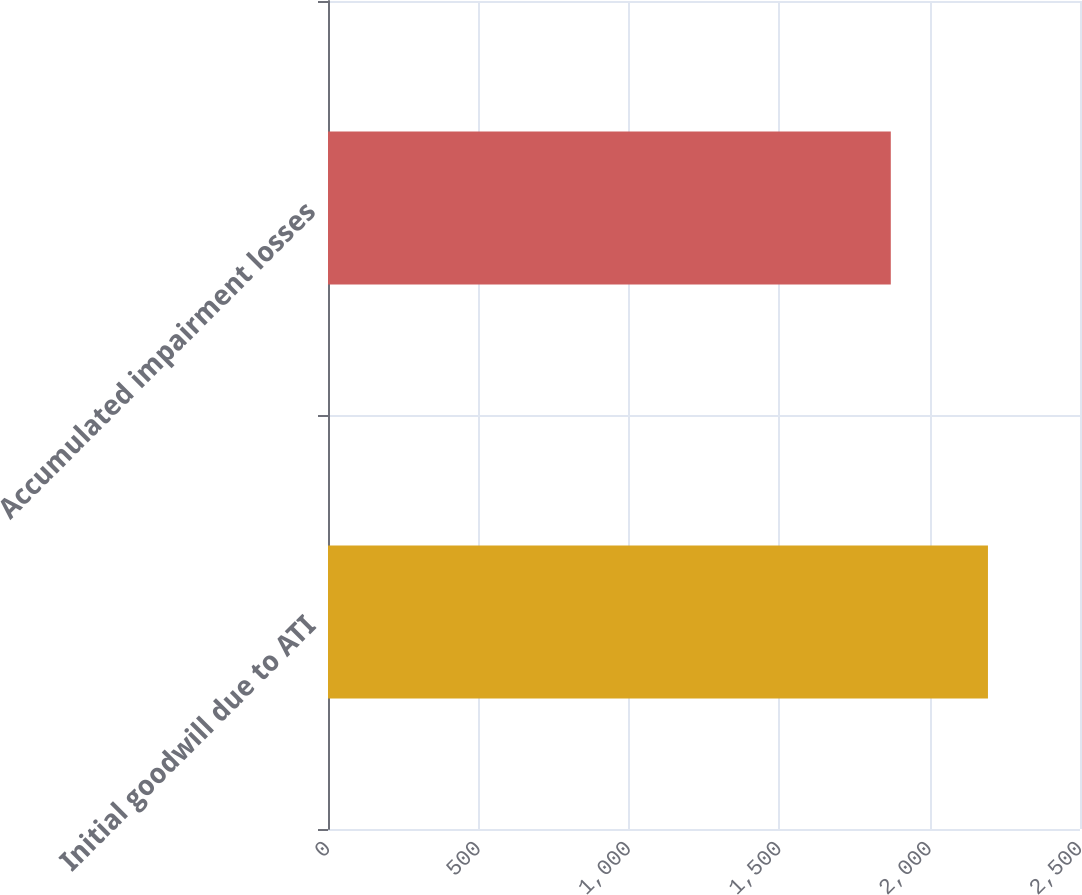<chart> <loc_0><loc_0><loc_500><loc_500><bar_chart><fcel>Initial goodwill due to ATI<fcel>Accumulated impairment losses<nl><fcel>2194<fcel>1871<nl></chart> 